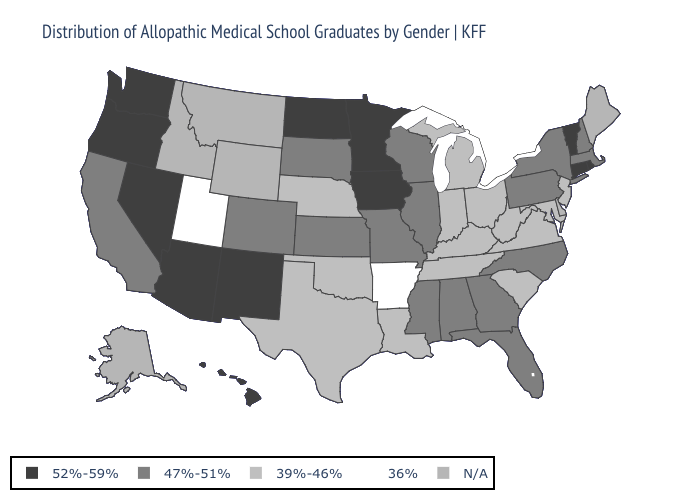What is the value of Kansas?
Give a very brief answer. 47%-51%. Name the states that have a value in the range 52%-59%?
Short answer required. Arizona, Connecticut, Hawaii, Iowa, Minnesota, Nevada, New Mexico, North Dakota, Oregon, Rhode Island, Vermont, Washington. What is the highest value in the USA?
Answer briefly. 52%-59%. Name the states that have a value in the range 39%-46%?
Keep it brief. Indiana, Kentucky, Louisiana, Maryland, Michigan, Nebraska, New Jersey, Ohio, Oklahoma, South Carolina, Tennessee, Texas, Virginia, West Virginia. What is the value of Colorado?
Short answer required. 47%-51%. Name the states that have a value in the range 39%-46%?
Write a very short answer. Indiana, Kentucky, Louisiana, Maryland, Michigan, Nebraska, New Jersey, Ohio, Oklahoma, South Carolina, Tennessee, Texas, Virginia, West Virginia. What is the value of Massachusetts?
Concise answer only. 47%-51%. Name the states that have a value in the range 39%-46%?
Give a very brief answer. Indiana, Kentucky, Louisiana, Maryland, Michigan, Nebraska, New Jersey, Ohio, Oklahoma, South Carolina, Tennessee, Texas, Virginia, West Virginia. Which states have the lowest value in the USA?
Give a very brief answer. Arkansas, Utah. What is the value of Delaware?
Quick response, please. N/A. Which states hav the highest value in the Northeast?
Short answer required. Connecticut, Rhode Island, Vermont. What is the value of Arizona?
Answer briefly. 52%-59%. What is the value of Maine?
Be succinct. N/A. Name the states that have a value in the range N/A?
Give a very brief answer. Alaska, Delaware, Idaho, Maine, Montana, Wyoming. What is the lowest value in states that border West Virginia?
Keep it brief. 39%-46%. 